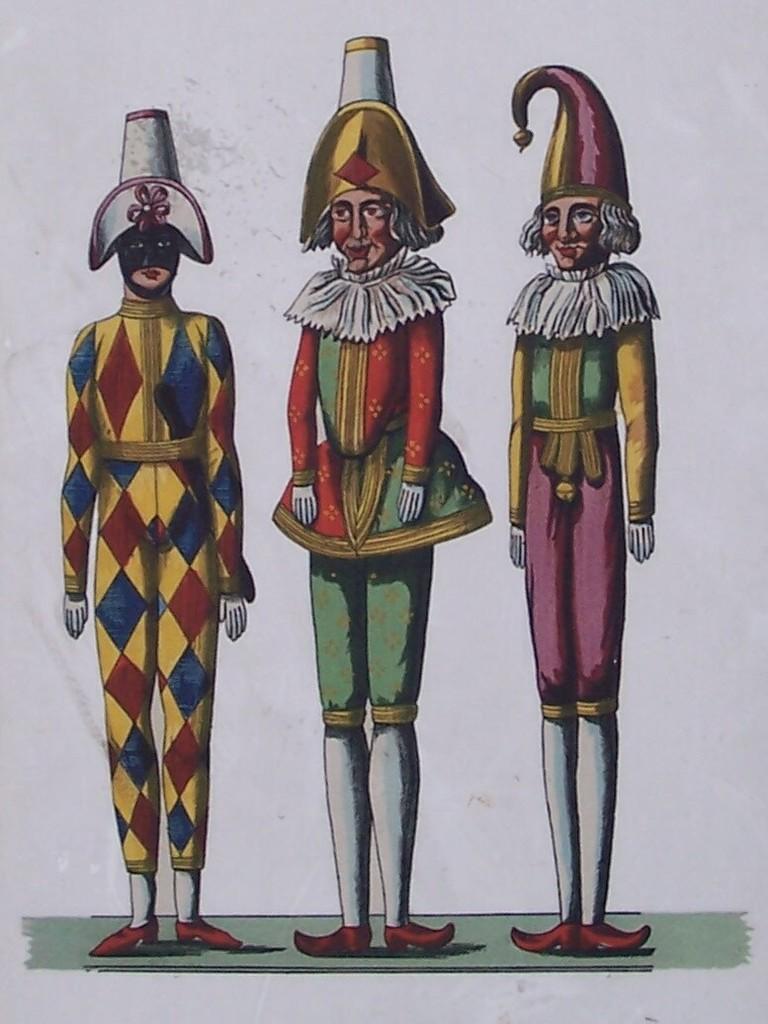In one or two sentences, can you explain what this image depicts? In this image I can see three toys in different color dresses. Background is in white color. 